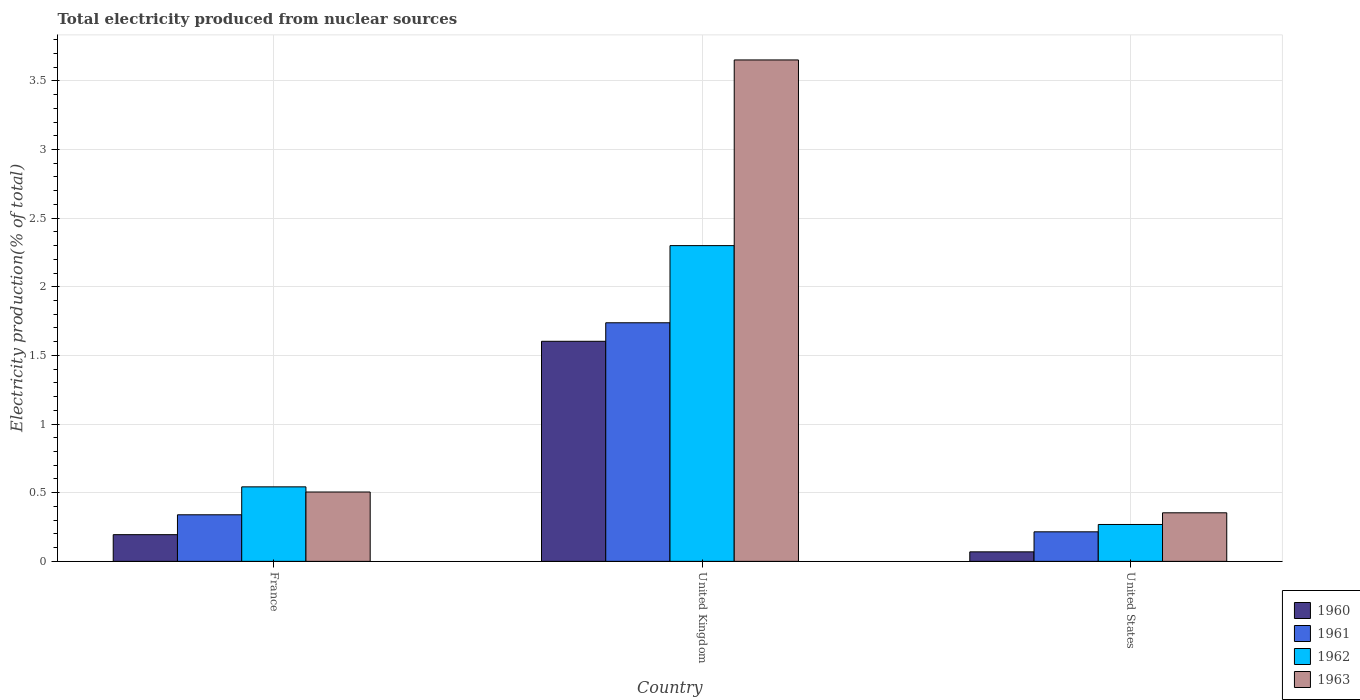How many groups of bars are there?
Ensure brevity in your answer.  3. Are the number of bars per tick equal to the number of legend labels?
Provide a succinct answer. Yes. How many bars are there on the 2nd tick from the right?
Provide a short and direct response. 4. What is the label of the 2nd group of bars from the left?
Your response must be concise. United Kingdom. What is the total electricity produced in 1963 in France?
Keep it short and to the point. 0.51. Across all countries, what is the maximum total electricity produced in 1960?
Your response must be concise. 1.6. Across all countries, what is the minimum total electricity produced in 1961?
Provide a short and direct response. 0.22. In which country was the total electricity produced in 1963 minimum?
Offer a very short reply. United States. What is the total total electricity produced in 1963 in the graph?
Offer a terse response. 4.51. What is the difference between the total electricity produced in 1961 in United Kingdom and that in United States?
Offer a very short reply. 1.52. What is the difference between the total electricity produced in 1961 in United Kingdom and the total electricity produced in 1960 in France?
Give a very brief answer. 1.54. What is the average total electricity produced in 1961 per country?
Ensure brevity in your answer.  0.76. What is the difference between the total electricity produced of/in 1962 and total electricity produced of/in 1963 in France?
Offer a very short reply. 0.04. In how many countries, is the total electricity produced in 1961 greater than 3.7 %?
Offer a very short reply. 0. What is the ratio of the total electricity produced in 1963 in France to that in United Kingdom?
Your answer should be compact. 0.14. Is the total electricity produced in 1960 in United Kingdom less than that in United States?
Give a very brief answer. No. Is the difference between the total electricity produced in 1962 in France and United States greater than the difference between the total electricity produced in 1963 in France and United States?
Offer a terse response. Yes. What is the difference between the highest and the second highest total electricity produced in 1963?
Ensure brevity in your answer.  -3.15. What is the difference between the highest and the lowest total electricity produced in 1961?
Make the answer very short. 1.52. In how many countries, is the total electricity produced in 1960 greater than the average total electricity produced in 1960 taken over all countries?
Provide a succinct answer. 1. Is the sum of the total electricity produced in 1963 in France and United States greater than the maximum total electricity produced in 1962 across all countries?
Provide a short and direct response. No. Is it the case that in every country, the sum of the total electricity produced in 1962 and total electricity produced in 1961 is greater than the sum of total electricity produced in 1960 and total electricity produced in 1963?
Provide a succinct answer. No. Is it the case that in every country, the sum of the total electricity produced in 1960 and total electricity produced in 1962 is greater than the total electricity produced in 1961?
Provide a short and direct response. Yes. How many bars are there?
Provide a succinct answer. 12. How many countries are there in the graph?
Give a very brief answer. 3. Does the graph contain grids?
Keep it short and to the point. Yes. How many legend labels are there?
Offer a terse response. 4. What is the title of the graph?
Offer a very short reply. Total electricity produced from nuclear sources. What is the label or title of the Y-axis?
Your response must be concise. Electricity production(% of total). What is the Electricity production(% of total) in 1960 in France?
Your answer should be compact. 0.19. What is the Electricity production(% of total) in 1961 in France?
Offer a very short reply. 0.34. What is the Electricity production(% of total) of 1962 in France?
Your response must be concise. 0.54. What is the Electricity production(% of total) of 1963 in France?
Your answer should be very brief. 0.51. What is the Electricity production(% of total) of 1960 in United Kingdom?
Provide a short and direct response. 1.6. What is the Electricity production(% of total) in 1961 in United Kingdom?
Provide a short and direct response. 1.74. What is the Electricity production(% of total) in 1962 in United Kingdom?
Give a very brief answer. 2.3. What is the Electricity production(% of total) of 1963 in United Kingdom?
Offer a terse response. 3.65. What is the Electricity production(% of total) of 1960 in United States?
Offer a terse response. 0.07. What is the Electricity production(% of total) in 1961 in United States?
Provide a succinct answer. 0.22. What is the Electricity production(% of total) in 1962 in United States?
Offer a very short reply. 0.27. What is the Electricity production(% of total) of 1963 in United States?
Give a very brief answer. 0.35. Across all countries, what is the maximum Electricity production(% of total) of 1960?
Provide a short and direct response. 1.6. Across all countries, what is the maximum Electricity production(% of total) in 1961?
Ensure brevity in your answer.  1.74. Across all countries, what is the maximum Electricity production(% of total) of 1962?
Offer a terse response. 2.3. Across all countries, what is the maximum Electricity production(% of total) of 1963?
Keep it short and to the point. 3.65. Across all countries, what is the minimum Electricity production(% of total) in 1960?
Give a very brief answer. 0.07. Across all countries, what is the minimum Electricity production(% of total) of 1961?
Provide a short and direct response. 0.22. Across all countries, what is the minimum Electricity production(% of total) of 1962?
Offer a very short reply. 0.27. Across all countries, what is the minimum Electricity production(% of total) of 1963?
Provide a succinct answer. 0.35. What is the total Electricity production(% of total) in 1960 in the graph?
Your answer should be very brief. 1.87. What is the total Electricity production(% of total) of 1961 in the graph?
Provide a short and direct response. 2.29. What is the total Electricity production(% of total) of 1962 in the graph?
Your answer should be compact. 3.11. What is the total Electricity production(% of total) of 1963 in the graph?
Your response must be concise. 4.51. What is the difference between the Electricity production(% of total) in 1960 in France and that in United Kingdom?
Ensure brevity in your answer.  -1.41. What is the difference between the Electricity production(% of total) of 1961 in France and that in United Kingdom?
Provide a short and direct response. -1.4. What is the difference between the Electricity production(% of total) of 1962 in France and that in United Kingdom?
Make the answer very short. -1.76. What is the difference between the Electricity production(% of total) in 1963 in France and that in United Kingdom?
Make the answer very short. -3.15. What is the difference between the Electricity production(% of total) in 1960 in France and that in United States?
Make the answer very short. 0.13. What is the difference between the Electricity production(% of total) in 1961 in France and that in United States?
Provide a short and direct response. 0.12. What is the difference between the Electricity production(% of total) of 1962 in France and that in United States?
Ensure brevity in your answer.  0.27. What is the difference between the Electricity production(% of total) of 1963 in France and that in United States?
Your answer should be very brief. 0.15. What is the difference between the Electricity production(% of total) of 1960 in United Kingdom and that in United States?
Give a very brief answer. 1.53. What is the difference between the Electricity production(% of total) of 1961 in United Kingdom and that in United States?
Provide a succinct answer. 1.52. What is the difference between the Electricity production(% of total) in 1962 in United Kingdom and that in United States?
Provide a succinct answer. 2.03. What is the difference between the Electricity production(% of total) in 1963 in United Kingdom and that in United States?
Give a very brief answer. 3.3. What is the difference between the Electricity production(% of total) in 1960 in France and the Electricity production(% of total) in 1961 in United Kingdom?
Give a very brief answer. -1.54. What is the difference between the Electricity production(% of total) in 1960 in France and the Electricity production(% of total) in 1962 in United Kingdom?
Ensure brevity in your answer.  -2.11. What is the difference between the Electricity production(% of total) of 1960 in France and the Electricity production(% of total) of 1963 in United Kingdom?
Give a very brief answer. -3.46. What is the difference between the Electricity production(% of total) of 1961 in France and the Electricity production(% of total) of 1962 in United Kingdom?
Offer a very short reply. -1.96. What is the difference between the Electricity production(% of total) in 1961 in France and the Electricity production(% of total) in 1963 in United Kingdom?
Make the answer very short. -3.31. What is the difference between the Electricity production(% of total) in 1962 in France and the Electricity production(% of total) in 1963 in United Kingdom?
Ensure brevity in your answer.  -3.11. What is the difference between the Electricity production(% of total) in 1960 in France and the Electricity production(% of total) in 1961 in United States?
Make the answer very short. -0.02. What is the difference between the Electricity production(% of total) of 1960 in France and the Electricity production(% of total) of 1962 in United States?
Keep it short and to the point. -0.07. What is the difference between the Electricity production(% of total) in 1960 in France and the Electricity production(% of total) in 1963 in United States?
Offer a terse response. -0.16. What is the difference between the Electricity production(% of total) in 1961 in France and the Electricity production(% of total) in 1962 in United States?
Offer a very short reply. 0.07. What is the difference between the Electricity production(% of total) of 1961 in France and the Electricity production(% of total) of 1963 in United States?
Your response must be concise. -0.01. What is the difference between the Electricity production(% of total) in 1962 in France and the Electricity production(% of total) in 1963 in United States?
Keep it short and to the point. 0.19. What is the difference between the Electricity production(% of total) of 1960 in United Kingdom and the Electricity production(% of total) of 1961 in United States?
Provide a short and direct response. 1.39. What is the difference between the Electricity production(% of total) of 1960 in United Kingdom and the Electricity production(% of total) of 1962 in United States?
Offer a very short reply. 1.33. What is the difference between the Electricity production(% of total) in 1960 in United Kingdom and the Electricity production(% of total) in 1963 in United States?
Offer a very short reply. 1.25. What is the difference between the Electricity production(% of total) in 1961 in United Kingdom and the Electricity production(% of total) in 1962 in United States?
Your answer should be compact. 1.47. What is the difference between the Electricity production(% of total) in 1961 in United Kingdom and the Electricity production(% of total) in 1963 in United States?
Your response must be concise. 1.38. What is the difference between the Electricity production(% of total) of 1962 in United Kingdom and the Electricity production(% of total) of 1963 in United States?
Offer a very short reply. 1.95. What is the average Electricity production(% of total) of 1960 per country?
Make the answer very short. 0.62. What is the average Electricity production(% of total) in 1961 per country?
Provide a short and direct response. 0.76. What is the average Electricity production(% of total) in 1962 per country?
Your answer should be compact. 1.04. What is the average Electricity production(% of total) of 1963 per country?
Provide a short and direct response. 1.5. What is the difference between the Electricity production(% of total) of 1960 and Electricity production(% of total) of 1961 in France?
Offer a terse response. -0.14. What is the difference between the Electricity production(% of total) of 1960 and Electricity production(% of total) of 1962 in France?
Provide a short and direct response. -0.35. What is the difference between the Electricity production(% of total) in 1960 and Electricity production(% of total) in 1963 in France?
Your answer should be very brief. -0.31. What is the difference between the Electricity production(% of total) of 1961 and Electricity production(% of total) of 1962 in France?
Give a very brief answer. -0.2. What is the difference between the Electricity production(% of total) in 1961 and Electricity production(% of total) in 1963 in France?
Keep it short and to the point. -0.17. What is the difference between the Electricity production(% of total) in 1962 and Electricity production(% of total) in 1963 in France?
Ensure brevity in your answer.  0.04. What is the difference between the Electricity production(% of total) of 1960 and Electricity production(% of total) of 1961 in United Kingdom?
Give a very brief answer. -0.13. What is the difference between the Electricity production(% of total) of 1960 and Electricity production(% of total) of 1962 in United Kingdom?
Ensure brevity in your answer.  -0.7. What is the difference between the Electricity production(% of total) in 1960 and Electricity production(% of total) in 1963 in United Kingdom?
Keep it short and to the point. -2.05. What is the difference between the Electricity production(% of total) in 1961 and Electricity production(% of total) in 1962 in United Kingdom?
Provide a succinct answer. -0.56. What is the difference between the Electricity production(% of total) in 1961 and Electricity production(% of total) in 1963 in United Kingdom?
Your response must be concise. -1.91. What is the difference between the Electricity production(% of total) of 1962 and Electricity production(% of total) of 1963 in United Kingdom?
Keep it short and to the point. -1.35. What is the difference between the Electricity production(% of total) of 1960 and Electricity production(% of total) of 1961 in United States?
Provide a short and direct response. -0.15. What is the difference between the Electricity production(% of total) of 1960 and Electricity production(% of total) of 1962 in United States?
Your answer should be compact. -0.2. What is the difference between the Electricity production(% of total) of 1960 and Electricity production(% of total) of 1963 in United States?
Your answer should be very brief. -0.28. What is the difference between the Electricity production(% of total) in 1961 and Electricity production(% of total) in 1962 in United States?
Give a very brief answer. -0.05. What is the difference between the Electricity production(% of total) of 1961 and Electricity production(% of total) of 1963 in United States?
Keep it short and to the point. -0.14. What is the difference between the Electricity production(% of total) of 1962 and Electricity production(% of total) of 1963 in United States?
Provide a succinct answer. -0.09. What is the ratio of the Electricity production(% of total) in 1960 in France to that in United Kingdom?
Offer a terse response. 0.12. What is the ratio of the Electricity production(% of total) of 1961 in France to that in United Kingdom?
Make the answer very short. 0.2. What is the ratio of the Electricity production(% of total) of 1962 in France to that in United Kingdom?
Ensure brevity in your answer.  0.24. What is the ratio of the Electricity production(% of total) in 1963 in France to that in United Kingdom?
Keep it short and to the point. 0.14. What is the ratio of the Electricity production(% of total) in 1960 in France to that in United States?
Make the answer very short. 2.81. What is the ratio of the Electricity production(% of total) of 1961 in France to that in United States?
Keep it short and to the point. 1.58. What is the ratio of the Electricity production(% of total) in 1962 in France to that in United States?
Offer a terse response. 2.02. What is the ratio of the Electricity production(% of total) in 1963 in France to that in United States?
Offer a very short reply. 1.43. What is the ratio of the Electricity production(% of total) of 1960 in United Kingdom to that in United States?
Your response must be concise. 23.14. What is the ratio of the Electricity production(% of total) in 1961 in United Kingdom to that in United States?
Your response must be concise. 8.08. What is the ratio of the Electricity production(% of total) in 1962 in United Kingdom to that in United States?
Your answer should be compact. 8.56. What is the ratio of the Electricity production(% of total) of 1963 in United Kingdom to that in United States?
Your response must be concise. 10.32. What is the difference between the highest and the second highest Electricity production(% of total) of 1960?
Provide a succinct answer. 1.41. What is the difference between the highest and the second highest Electricity production(% of total) of 1961?
Your answer should be compact. 1.4. What is the difference between the highest and the second highest Electricity production(% of total) of 1962?
Your answer should be compact. 1.76. What is the difference between the highest and the second highest Electricity production(% of total) of 1963?
Offer a very short reply. 3.15. What is the difference between the highest and the lowest Electricity production(% of total) of 1960?
Make the answer very short. 1.53. What is the difference between the highest and the lowest Electricity production(% of total) of 1961?
Provide a succinct answer. 1.52. What is the difference between the highest and the lowest Electricity production(% of total) of 1962?
Provide a short and direct response. 2.03. What is the difference between the highest and the lowest Electricity production(% of total) of 1963?
Offer a very short reply. 3.3. 